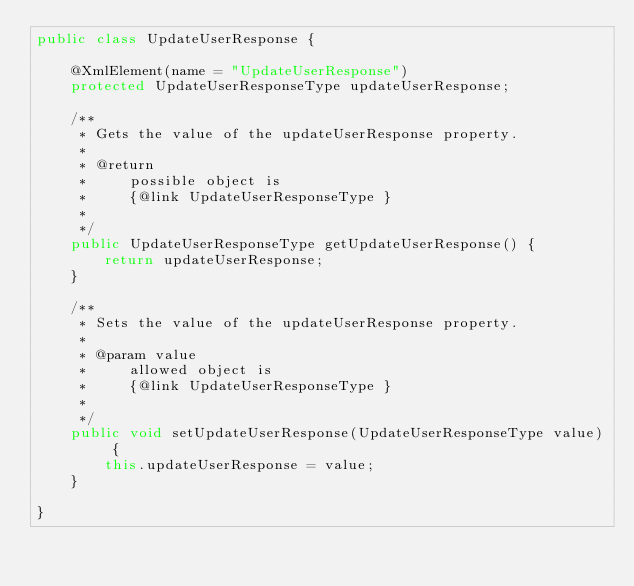Convert code to text. <code><loc_0><loc_0><loc_500><loc_500><_Java_>public class UpdateUserResponse {

    @XmlElement(name = "UpdateUserResponse")
    protected UpdateUserResponseType updateUserResponse;

    /**
     * Gets the value of the updateUserResponse property.
     * 
     * @return
     *     possible object is
     *     {@link UpdateUserResponseType }
     *     
     */
    public UpdateUserResponseType getUpdateUserResponse() {
        return updateUserResponse;
    }

    /**
     * Sets the value of the updateUserResponse property.
     * 
     * @param value
     *     allowed object is
     *     {@link UpdateUserResponseType }
     *     
     */
    public void setUpdateUserResponse(UpdateUserResponseType value) {
        this.updateUserResponse = value;
    }

}
</code> 